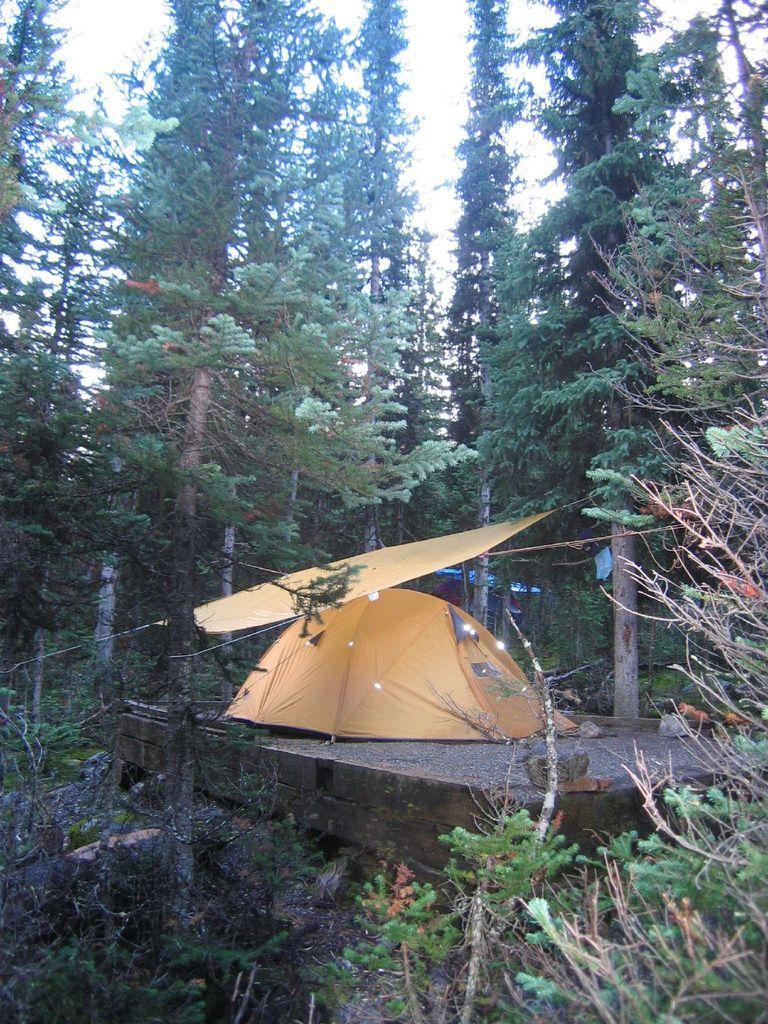Can you describe this image briefly? In this picture we see many tall trees. We also have a tent built on the ground. 